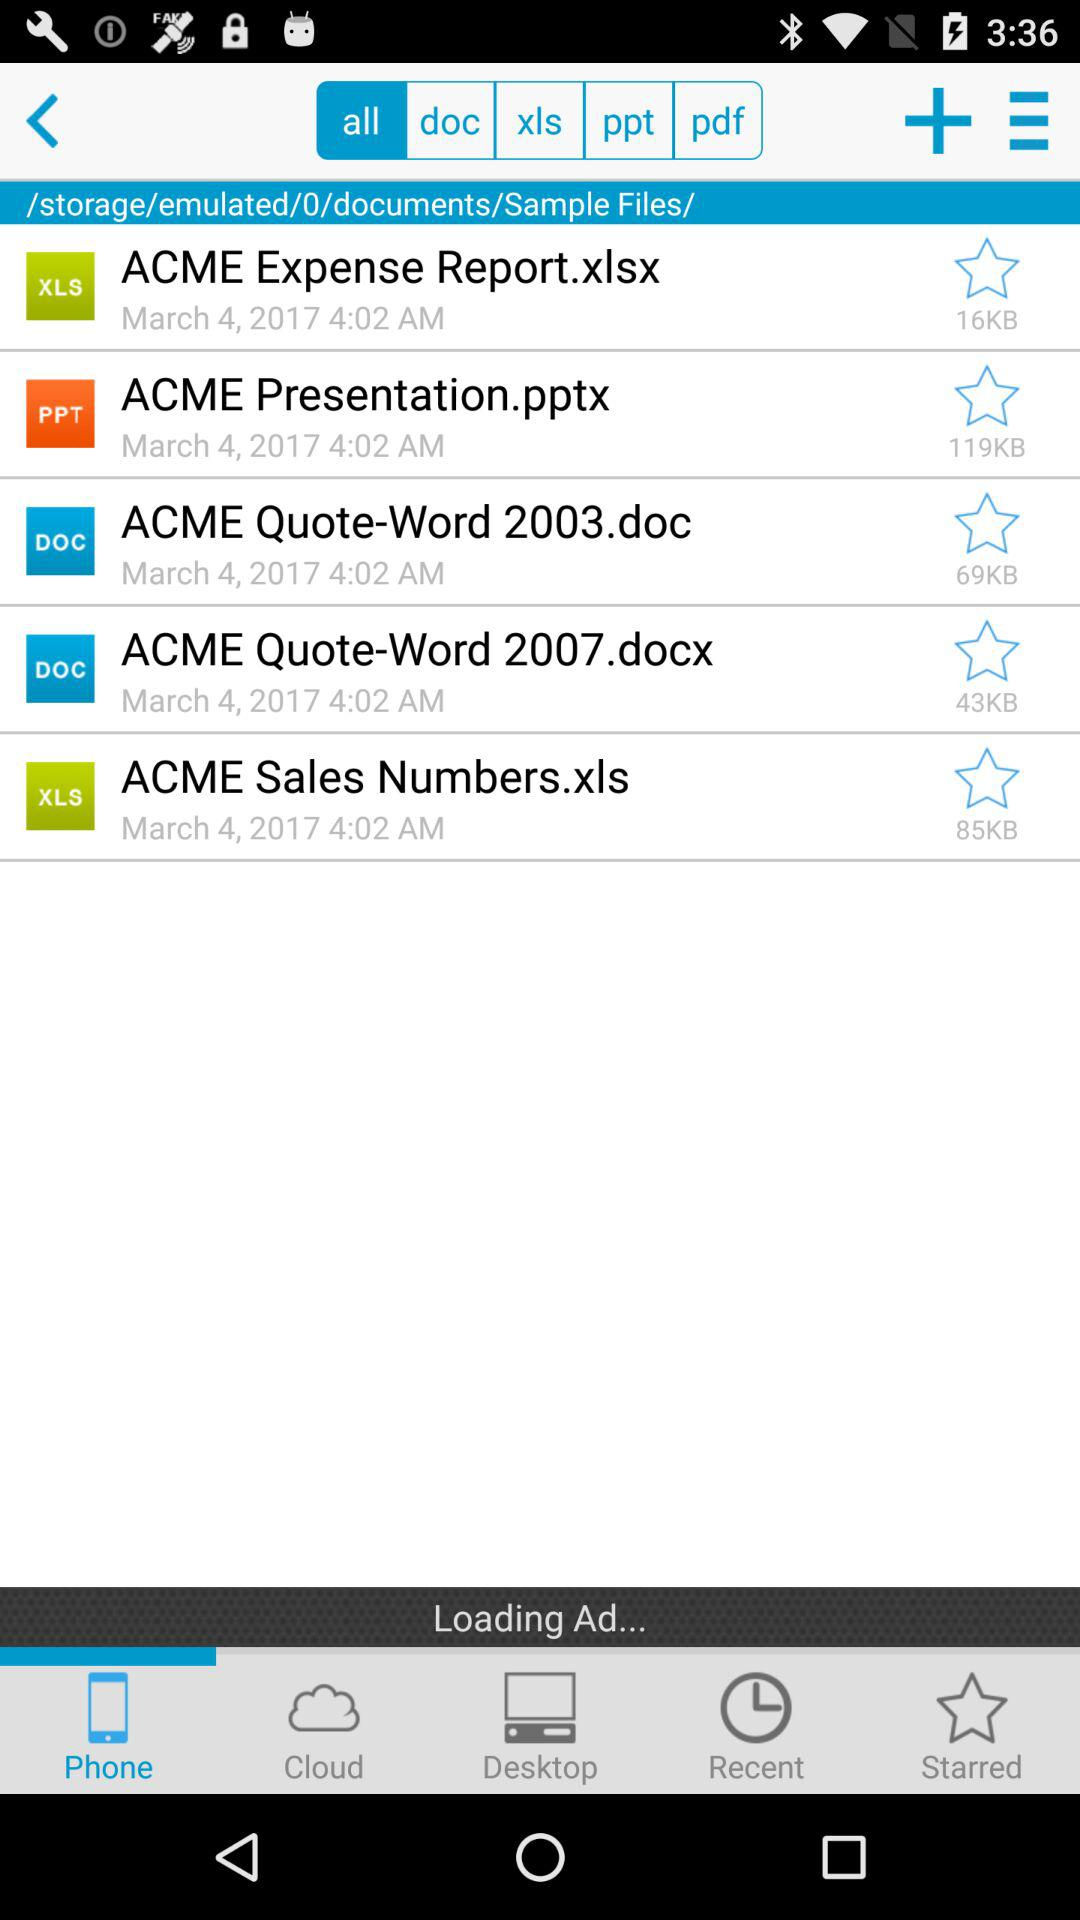Which tab is selected? The selected tabs are "all" and "Phone". 